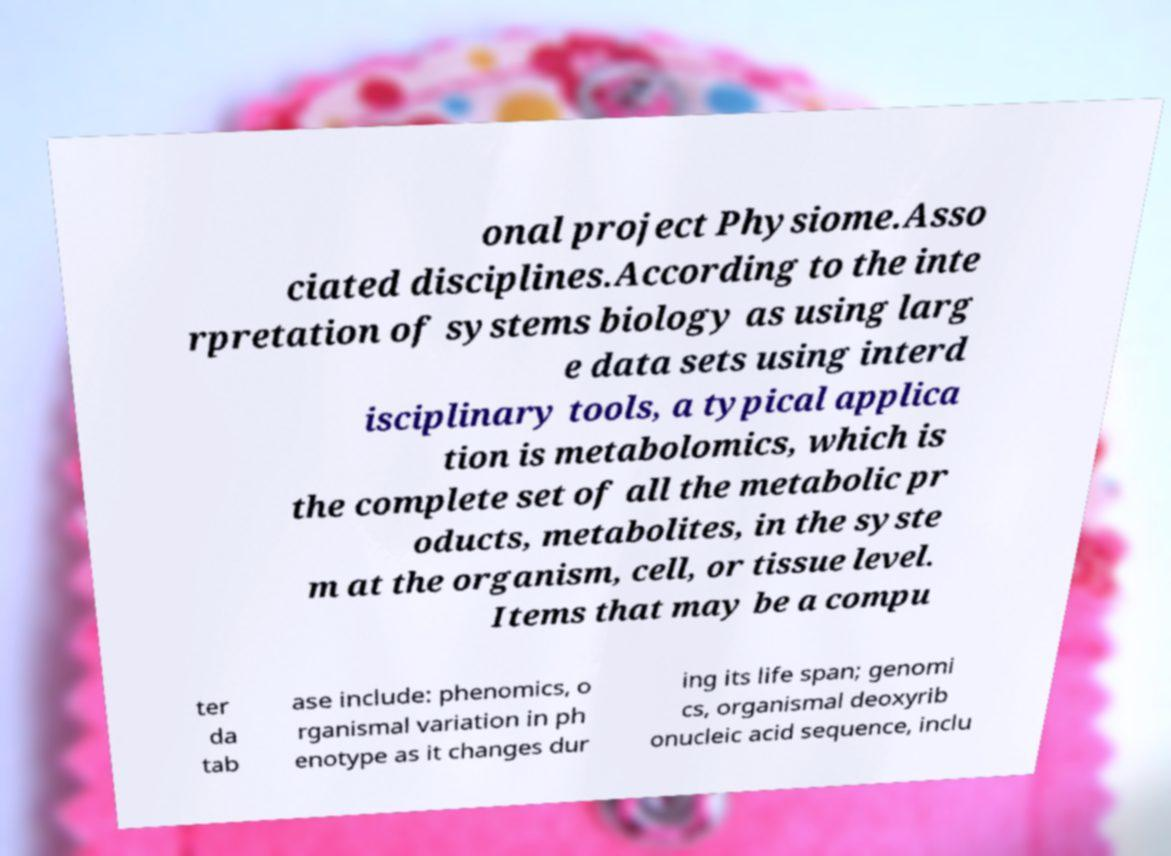Please identify and transcribe the text found in this image. onal project Physiome.Asso ciated disciplines.According to the inte rpretation of systems biology as using larg e data sets using interd isciplinary tools, a typical applica tion is metabolomics, which is the complete set of all the metabolic pr oducts, metabolites, in the syste m at the organism, cell, or tissue level. Items that may be a compu ter da tab ase include: phenomics, o rganismal variation in ph enotype as it changes dur ing its life span; genomi cs, organismal deoxyrib onucleic acid sequence, inclu 